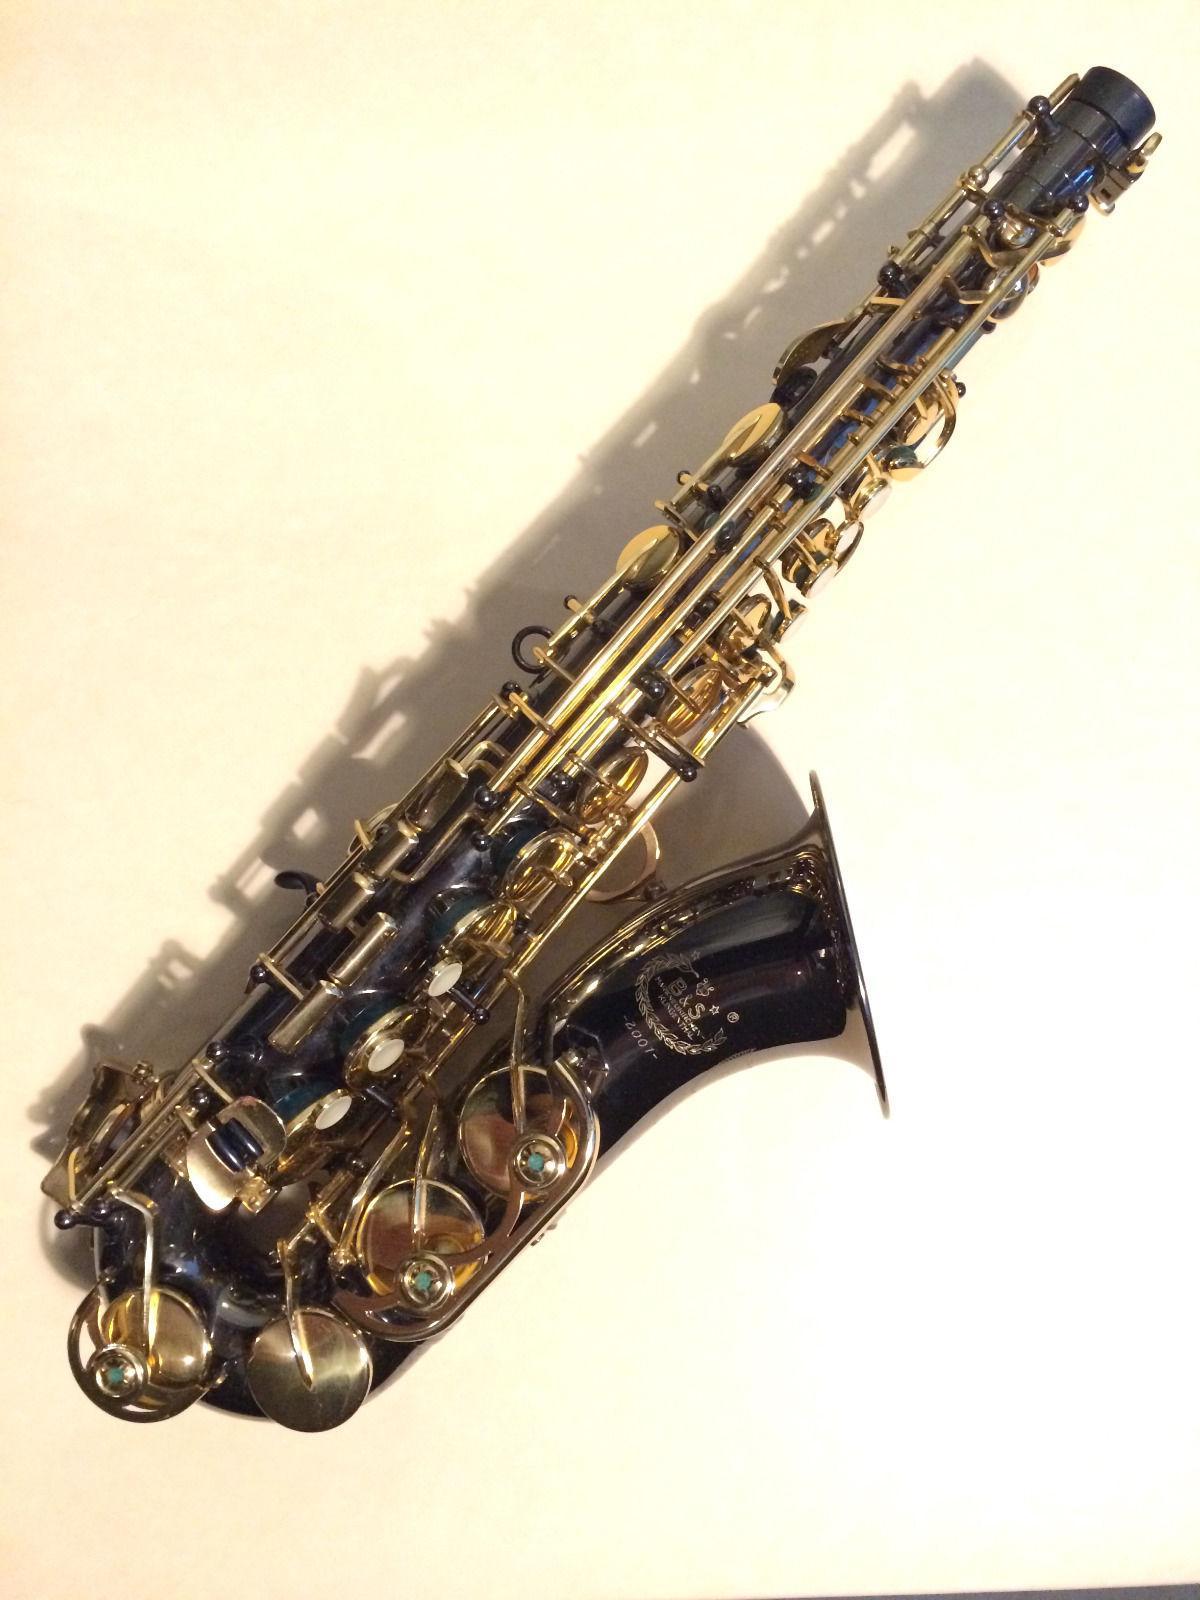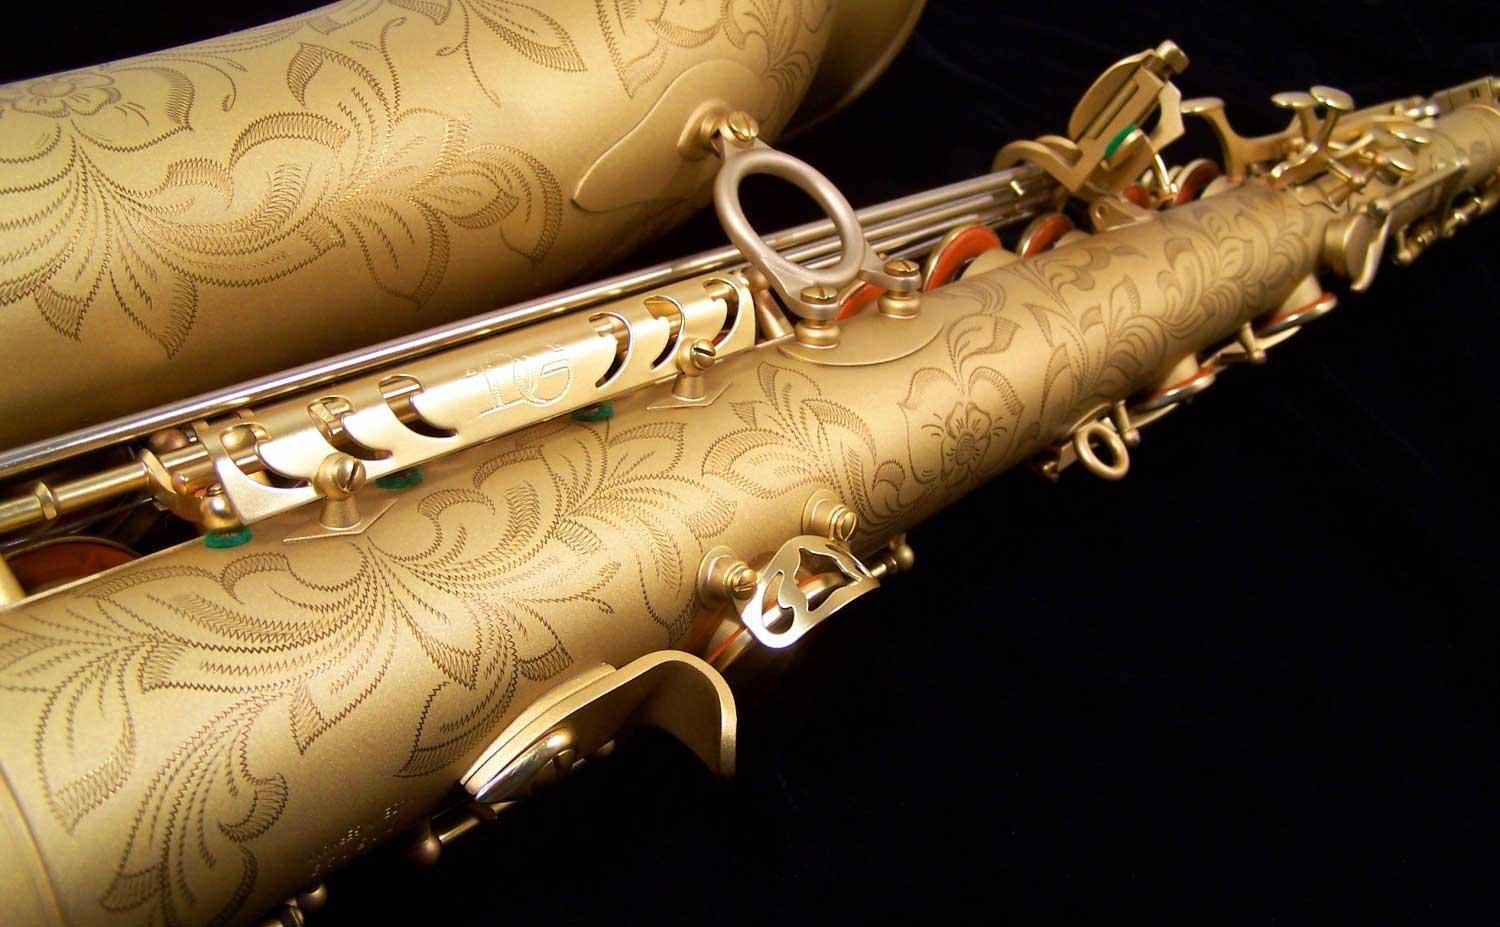The first image is the image on the left, the second image is the image on the right. Given the left and right images, does the statement "An image shows a saxophone displayed with its open, black-lined case." hold true? Answer yes or no. No. The first image is the image on the left, the second image is the image on the right. Examine the images to the left and right. Is the description "One saxophone has two extra mouth pieces beside it and one saxophone is shown with a black lined case." accurate? Answer yes or no. No. 